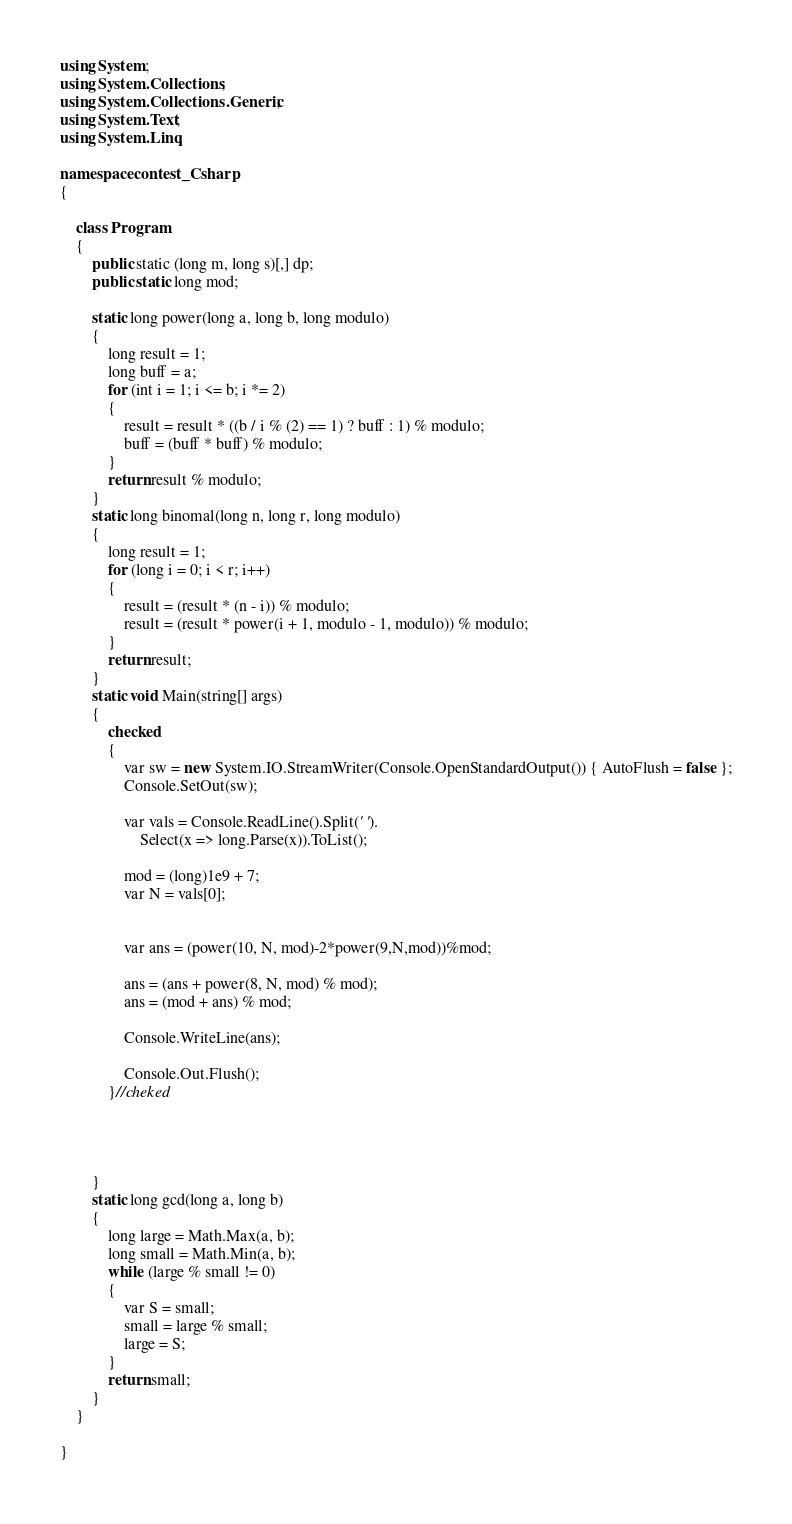<code> <loc_0><loc_0><loc_500><loc_500><_C#_>using System;
using System.Collections;
using System.Collections.Generic;
using System.Text;
using System.Linq;

namespace contest_Csharp
{

    class Program
    {
        public static (long m, long s)[,] dp;
        public static long mod;

        static long power(long a, long b, long modulo)
        {
            long result = 1;
            long buff = a;
            for (int i = 1; i <= b; i *= 2)
            {
                result = result * ((b / i % (2) == 1) ? buff : 1) % modulo;
                buff = (buff * buff) % modulo;
            }
            return result % modulo;
        }
        static long binomal(long n, long r, long modulo)
        {
            long result = 1;
            for (long i = 0; i < r; i++)
            {
                result = (result * (n - i)) % modulo;
                result = (result * power(i + 1, modulo - 1, modulo)) % modulo;
            }
            return result;
        }
        static void Main(string[] args)
        {
            checked
            {
                var sw = new System.IO.StreamWriter(Console.OpenStandardOutput()) { AutoFlush = false };
                Console.SetOut(sw);

                var vals = Console.ReadLine().Split(' ').
                    Select(x => long.Parse(x)).ToList();

                mod = (long)1e9 + 7;
                var N = vals[0];


                var ans = (power(10, N, mod)-2*power(9,N,mod))%mod;

                ans = (ans + power(8, N, mod) % mod);
                ans = (mod + ans) % mod;

                Console.WriteLine(ans);

                Console.Out.Flush();
            }//cheked




        }
        static long gcd(long a, long b)
        {
            long large = Math.Max(a, b);
            long small = Math.Min(a, b);
            while (large % small != 0)
            {
                var S = small;
                small = large % small;
                large = S;
            }
            return small;
        }
    }

}


</code> 